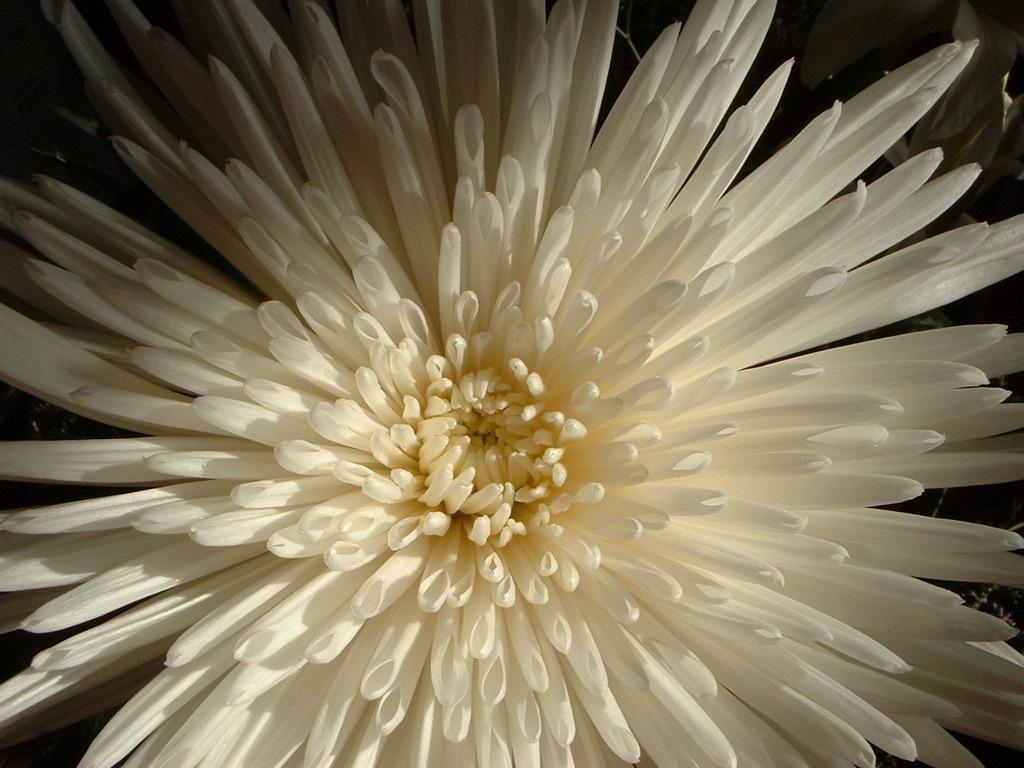What is the main subject of the image? The main subject of the image is a flower. Can you describe the color of the flower? The flower is white. What color is present in the middle of the flower? There is a yellow color in the middle of the flower. What can be observed about the background of the image? The background of the image is dark. Where is the can placed in the image? There is no can present in the image; it only features a white flower with a yellow center against a dark background. 